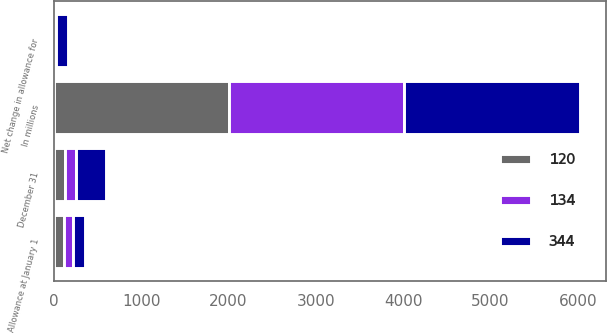Convert chart. <chart><loc_0><loc_0><loc_500><loc_500><stacked_bar_chart><ecel><fcel>In millions<fcel>Allowance at January 1<fcel>Net change in allowance for<fcel>December 31<nl><fcel>344<fcel>2008<fcel>134<fcel>135<fcel>344<nl><fcel>120<fcel>2007<fcel>120<fcel>3<fcel>134<nl><fcel>134<fcel>2006<fcel>100<fcel>20<fcel>120<nl></chart> 